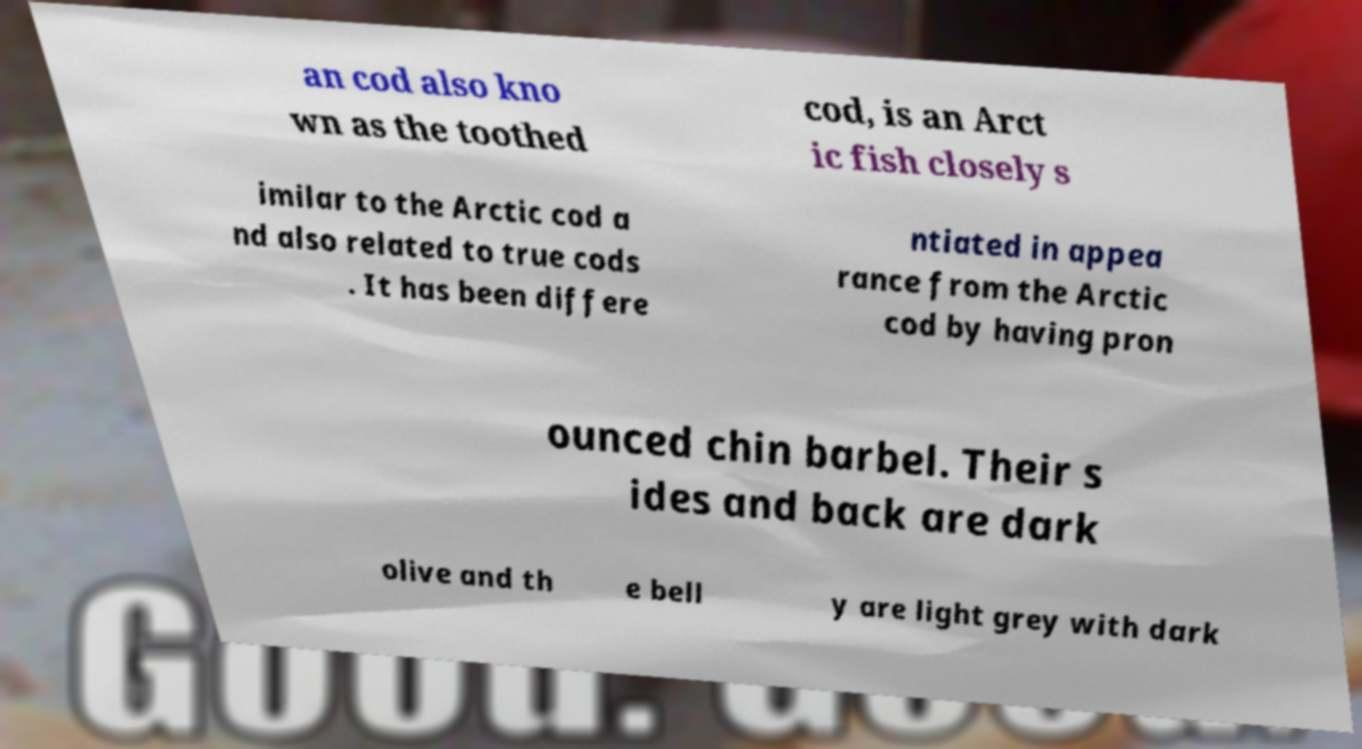There's text embedded in this image that I need extracted. Can you transcribe it verbatim? an cod also kno wn as the toothed cod, is an Arct ic fish closely s imilar to the Arctic cod a nd also related to true cods . It has been differe ntiated in appea rance from the Arctic cod by having pron ounced chin barbel. Their s ides and back are dark olive and th e bell y are light grey with dark 